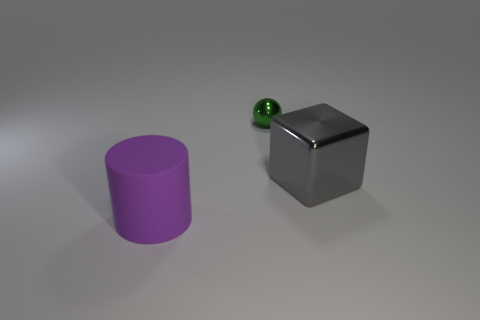What is the size of the metallic object that is left of the big thing behind the big matte cylinder?
Your answer should be very brief. Small. There is a metallic thing on the left side of the large object that is right of the cylinder; what shape is it?
Offer a terse response. Sphere. There is a object that is on the left side of the gray metal thing and behind the purple matte thing; how big is it?
Offer a very short reply. Small. What number of other objects are the same size as the cylinder?
Offer a very short reply. 1. The big thing on the right side of the thing that is to the left of the thing behind the gray metal thing is what shape?
Provide a succinct answer. Cube. There is a rubber object; does it have the same size as the shiny object that is in front of the tiny green shiny thing?
Your answer should be very brief. Yes. What color is the object that is both in front of the green shiny sphere and to the right of the rubber cylinder?
Give a very brief answer. Gray. How many other objects are the same shape as the gray metallic thing?
Offer a terse response. 0. Do the metal thing that is behind the big shiny block and the shiny thing that is in front of the green shiny thing have the same size?
Your answer should be very brief. No. Is there anything else that has the same material as the big purple cylinder?
Provide a short and direct response. No. 